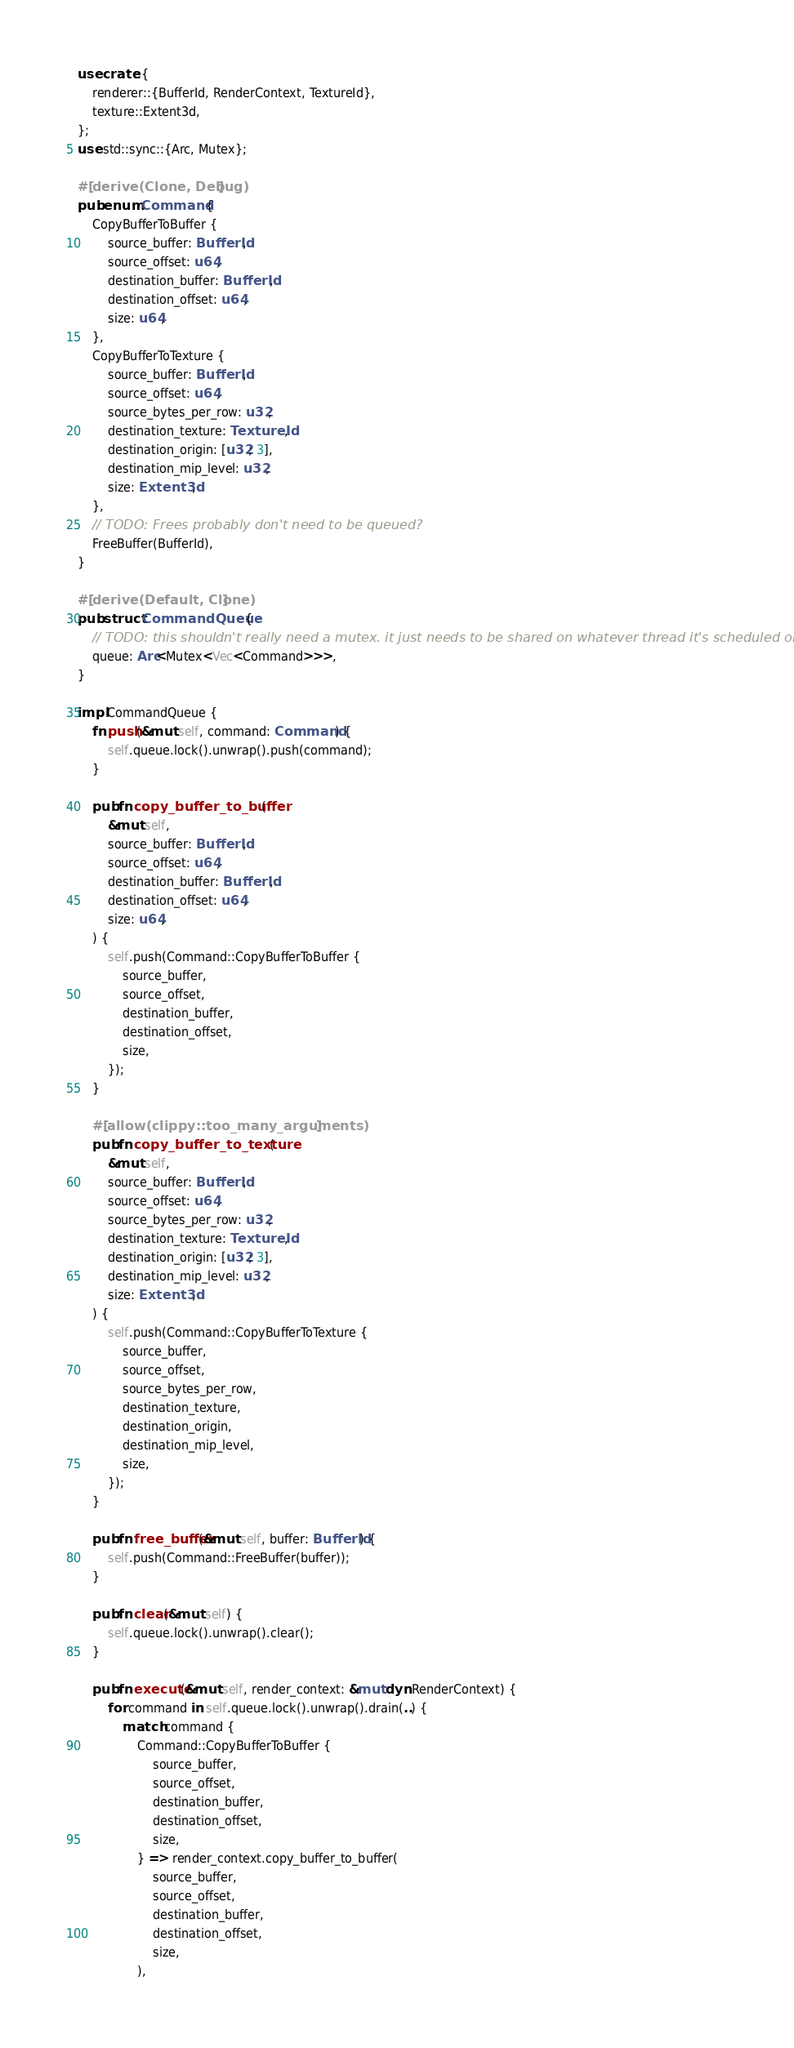Convert code to text. <code><loc_0><loc_0><loc_500><loc_500><_Rust_>use crate::{
    renderer::{BufferId, RenderContext, TextureId},
    texture::Extent3d,
};
use std::sync::{Arc, Mutex};

#[derive(Clone, Debug)]
pub enum Command {
    CopyBufferToBuffer {
        source_buffer: BufferId,
        source_offset: u64,
        destination_buffer: BufferId,
        destination_offset: u64,
        size: u64,
    },
    CopyBufferToTexture {
        source_buffer: BufferId,
        source_offset: u64,
        source_bytes_per_row: u32,
        destination_texture: TextureId,
        destination_origin: [u32; 3],
        destination_mip_level: u32,
        size: Extent3d,
    },
    // TODO: Frees probably don't need to be queued?
    FreeBuffer(BufferId),
}

#[derive(Default, Clone)]
pub struct CommandQueue {
    // TODO: this shouldn't really need a mutex. it just needs to be shared on whatever thread it's scheduled on
    queue: Arc<Mutex<Vec<Command>>>,
}

impl CommandQueue {
    fn push(&mut self, command: Command) {
        self.queue.lock().unwrap().push(command);
    }

    pub fn copy_buffer_to_buffer(
        &mut self,
        source_buffer: BufferId,
        source_offset: u64,
        destination_buffer: BufferId,
        destination_offset: u64,
        size: u64,
    ) {
        self.push(Command::CopyBufferToBuffer {
            source_buffer,
            source_offset,
            destination_buffer,
            destination_offset,
            size,
        });
    }

    #[allow(clippy::too_many_arguments)]
    pub fn copy_buffer_to_texture(
        &mut self,
        source_buffer: BufferId,
        source_offset: u64,
        source_bytes_per_row: u32,
        destination_texture: TextureId,
        destination_origin: [u32; 3],
        destination_mip_level: u32,
        size: Extent3d,
    ) {
        self.push(Command::CopyBufferToTexture {
            source_buffer,
            source_offset,
            source_bytes_per_row,
            destination_texture,
            destination_origin,
            destination_mip_level,
            size,
        });
    }

    pub fn free_buffer(&mut self, buffer: BufferId) {
        self.push(Command::FreeBuffer(buffer));
    }

    pub fn clear(&mut self) {
        self.queue.lock().unwrap().clear();
    }

    pub fn execute(&mut self, render_context: &mut dyn RenderContext) {
        for command in self.queue.lock().unwrap().drain(..) {
            match command {
                Command::CopyBufferToBuffer {
                    source_buffer,
                    source_offset,
                    destination_buffer,
                    destination_offset,
                    size,
                } => render_context.copy_buffer_to_buffer(
                    source_buffer,
                    source_offset,
                    destination_buffer,
                    destination_offset,
                    size,
                ),</code> 